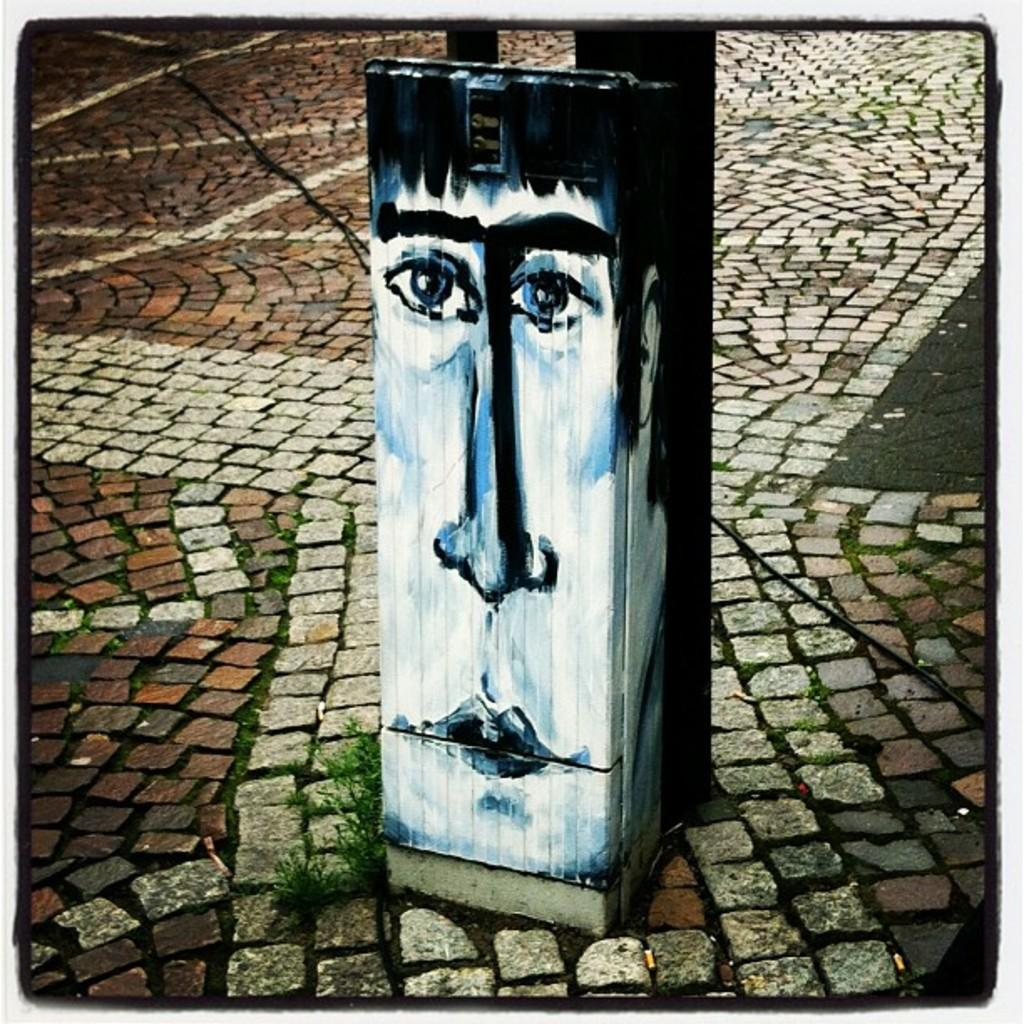What type of surface is visible in the image? There is ground in the image. What is located on the ground? There is a plant on the ground. What material is the wooden object made of? The wooden object is made of wood. What is depicted on the wooden object? There is a painting of a face on the wooden object. What type of toothpaste is advertised in the painting of the face on the wooden object? There is no toothpaste or advertisement present in the image. The wooden object features a painting of a face, but there is no mention of toothpaste or any advertisement. 